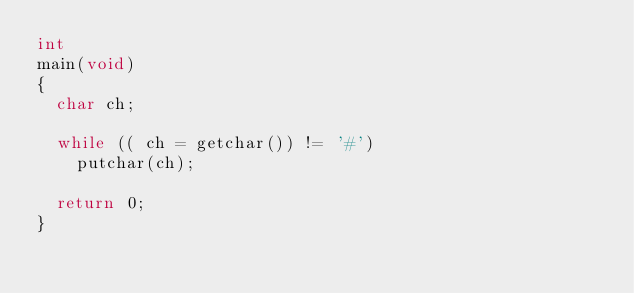<code> <loc_0><loc_0><loc_500><loc_500><_C_>int 
main(void) 
{
	char ch;

	while (( ch = getchar()) != '#')
		putchar(ch);

	return 0;
}
</code> 